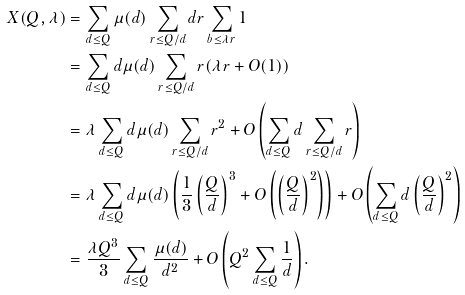Convert formula to latex. <formula><loc_0><loc_0><loc_500><loc_500>X ( Q , \lambda ) & = \sum _ { d \leq Q } \mu ( d ) \sum _ { r \leq Q / d } d r \sum _ { b \leq \lambda r } 1 \\ & = \sum _ { d \leq Q } d \mu ( d ) \sum _ { r \leq Q / d } r ( \lambda r + O ( 1 ) ) \\ & = \lambda \sum _ { d \leq Q } d \mu ( d ) \sum _ { r \leq Q / d } r ^ { 2 } + O \left ( \sum _ { d \leq Q } d \sum _ { r \leq Q / d } r \right ) \\ & = \lambda \sum _ { d \leq Q } d \mu ( d ) \left ( \frac { 1 } { 3 } \left ( \frac { Q } { d } \right ) ^ { 3 } + O \left ( \left ( \frac { Q } { d } \right ) ^ { 2 } \right ) \right ) + O \left ( \sum _ { d \leq Q } d \left ( \frac { Q } { d } \right ) ^ { 2 } \right ) \\ & = \frac { \lambda Q ^ { 3 } } { 3 } \sum _ { d \leq Q } \frac { \mu ( d ) } { d ^ { 2 } } + O \left ( Q ^ { 2 } \sum _ { d \leq Q } \frac { 1 } { d } \right ) .</formula> 